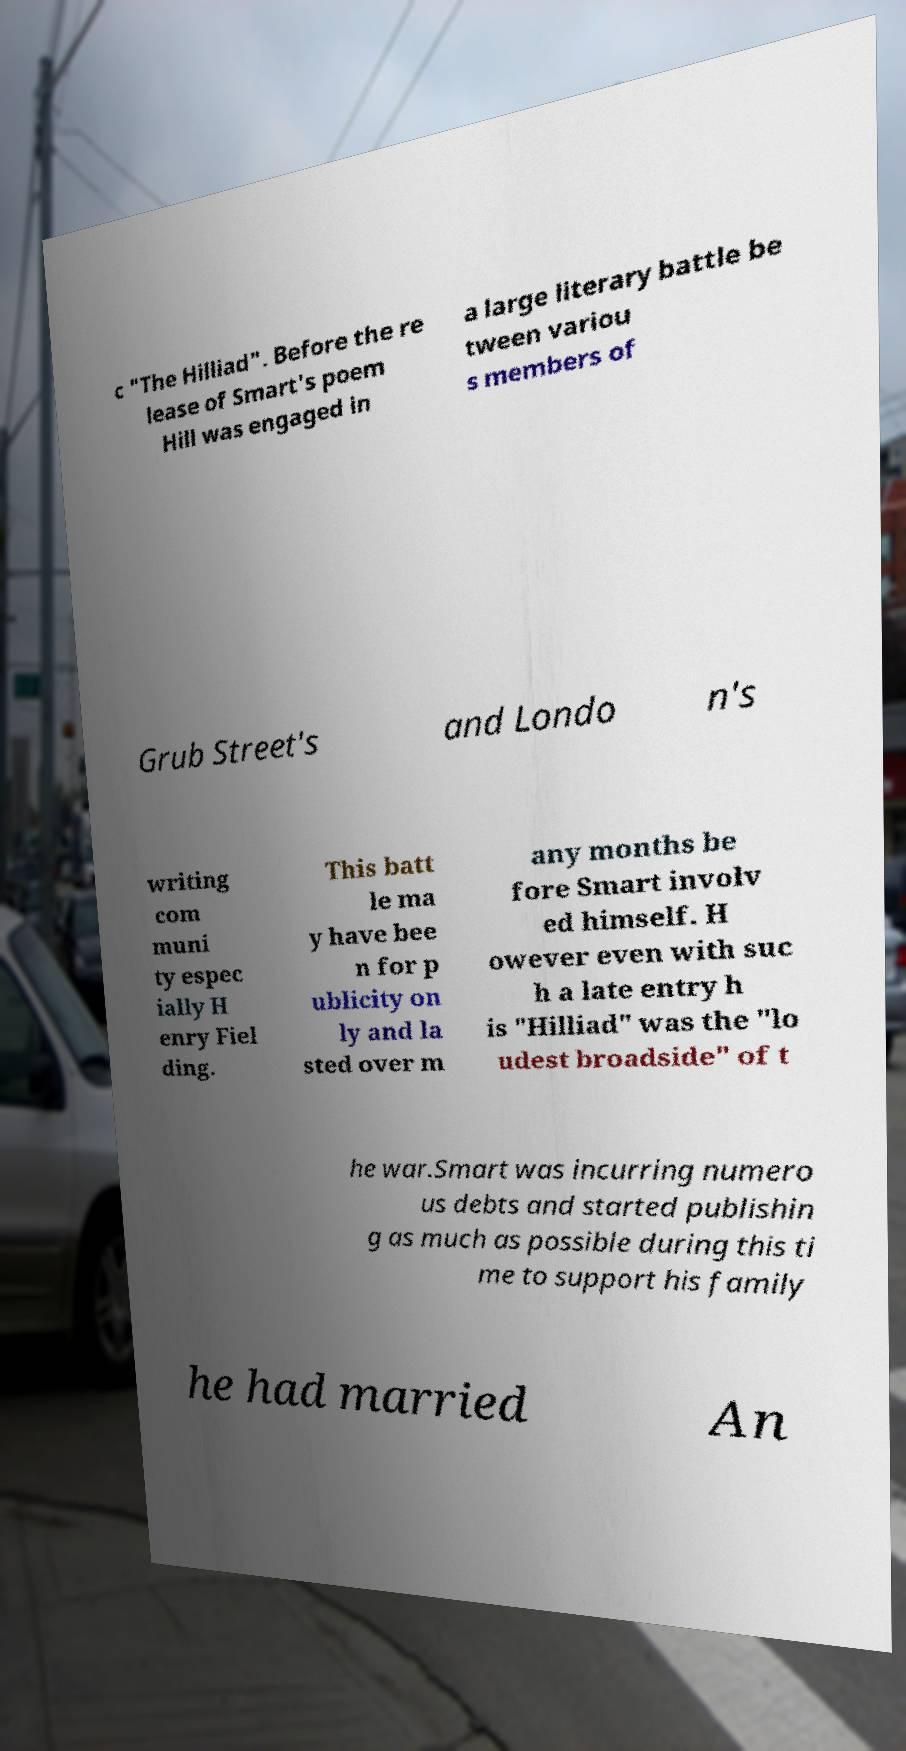I need the written content from this picture converted into text. Can you do that? c "The Hilliad". Before the re lease of Smart's poem Hill was engaged in a large literary battle be tween variou s members of Grub Street's and Londo n's writing com muni ty espec ially H enry Fiel ding. This batt le ma y have bee n for p ublicity on ly and la sted over m any months be fore Smart involv ed himself. H owever even with suc h a late entry h is "Hilliad" was the "lo udest broadside" of t he war.Smart was incurring numero us debts and started publishin g as much as possible during this ti me to support his family he had married An 